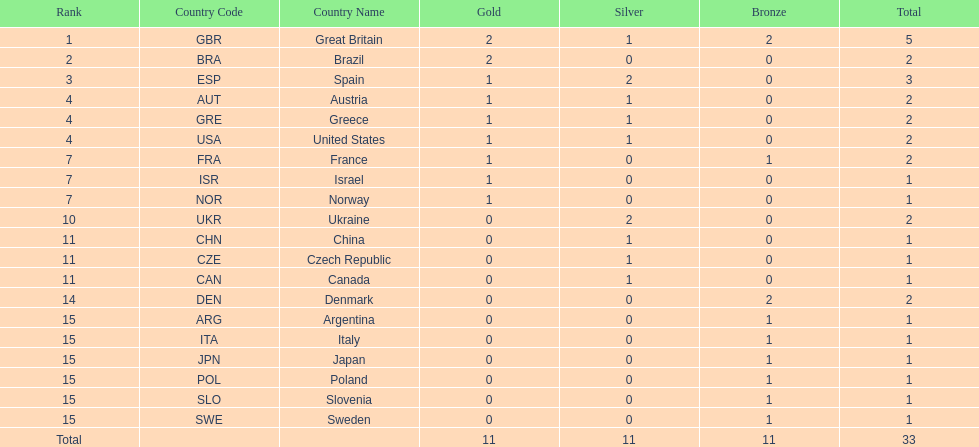How many countries won at least 1 gold and 1 silver medal? 5. 